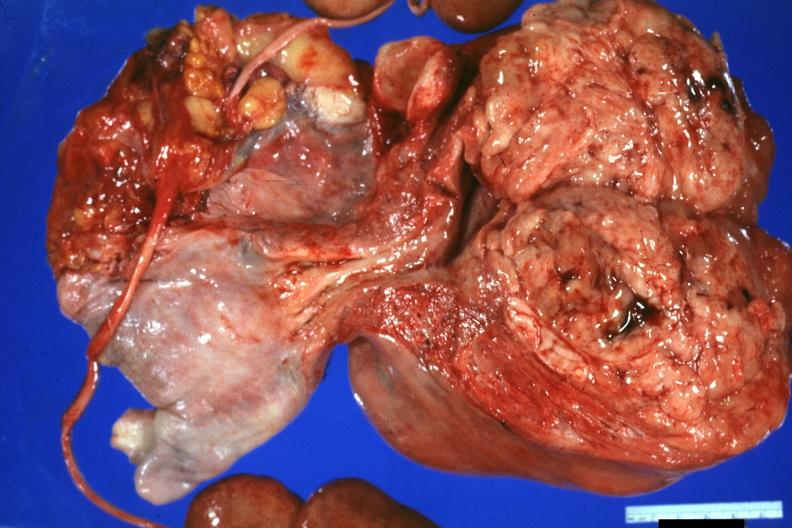does 70yof show nicely shown large neoplasm with fish flesh cerebriform appearance?
Answer the question using a single word or phrase. No 